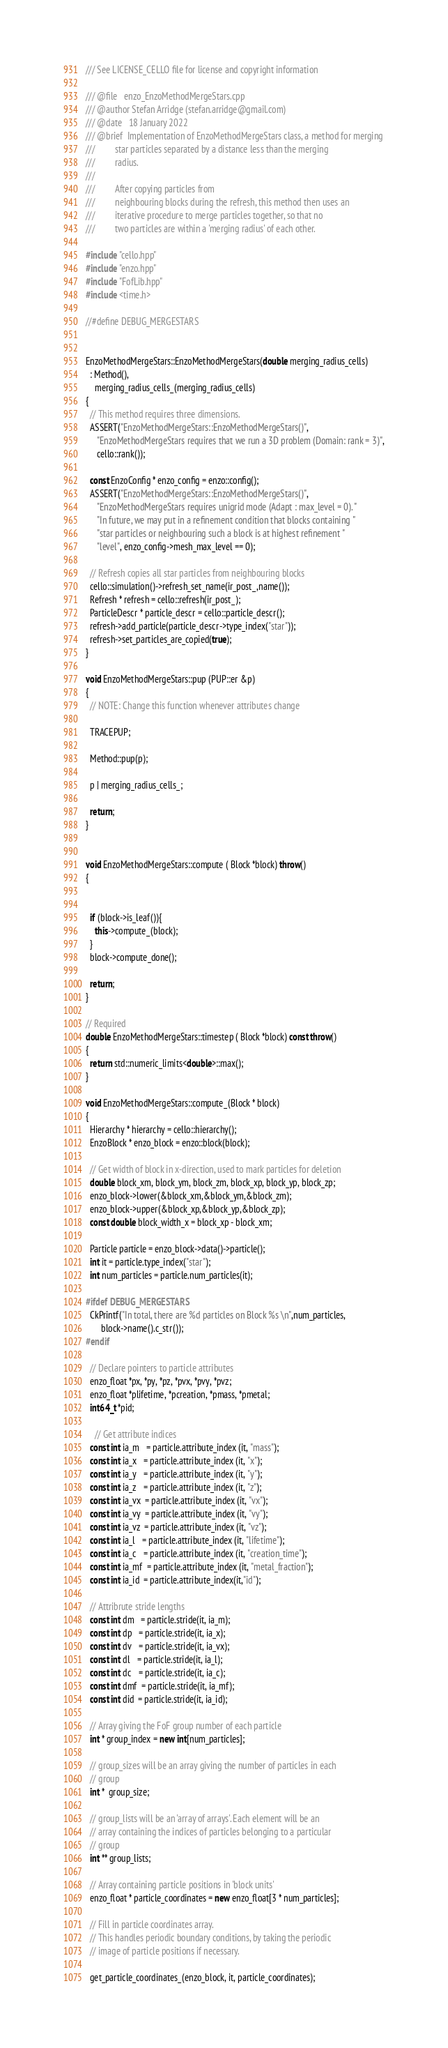<code> <loc_0><loc_0><loc_500><loc_500><_C++_>/// See LICENSE_CELLO file for license and copyright information

/// @file   enzo_EnzoMethodMergeStars.cpp
/// @author Stefan Arridge (stefan.arridge@gmail.com)
/// @date   18 January 2022
/// @brief  Implementation of EnzoMethodMergeStars class, a method for merging
///         star particles separated by a distance less than the merging
///         radius.
///
///         After copying particles from
///         neighbouring blocks during the refresh, this method then uses an
///         iterative procedure to merge particles together, so that no
///         two particles are within a 'merging radius' of each other.

#include "cello.hpp"
#include "enzo.hpp"
#include "FofLib.hpp"
#include <time.h>

//#define DEBUG_MERGESTARS


EnzoMethodMergeStars::EnzoMethodMergeStars(double merging_radius_cells)
  : Method(),
    merging_radius_cells_(merging_radius_cells)
{
  // This method requires three dimensions.
  ASSERT("EnzoMethodMergeStars::EnzoMethodMergeStars()",
	 "EnzoMethodMergeStars requires that we run a 3D problem (Domain: rank = 3)",
	 cello::rank());
  
  const EnzoConfig * enzo_config = enzo::config();
  ASSERT("EnzoMethodMergeStars::EnzoMethodMergeStars()",
	 "EnzoMethodMergeStars requires unigrid mode (Adapt : max_level = 0). "
	 "In future, we may put in a refinement condition that blocks containing "
	 "star particles or neighbouring such a block is at highest refinement "
	 "level", enzo_config->mesh_max_level == 0);

  // Refresh copies all star particles from neighbouring blocks
  cello::simulation()->refresh_set_name(ir_post_,name());
  Refresh * refresh = cello::refresh(ir_post_);
  ParticleDescr * particle_descr = cello::particle_descr();
  refresh->add_particle(particle_descr->type_index("star"));
  refresh->set_particles_are_copied(true);
}

void EnzoMethodMergeStars::pup (PUP::er &p)
{
  // NOTE: Change this function whenever attributes change

  TRACEPUP;

  Method::pup(p);

  p | merging_radius_cells_;
 
  return;
}


void EnzoMethodMergeStars::compute ( Block *block) throw()
{

  
  if (block->is_leaf()){
    this->compute_(block);
  }
  block->compute_done();

  return;
}

// Required
double EnzoMethodMergeStars::timestep ( Block *block) const throw()
{
  return std::numeric_limits<double>::max();
}

void EnzoMethodMergeStars::compute_(Block * block)
{
  Hierarchy * hierarchy = cello::hierarchy();  
  EnzoBlock * enzo_block = enzo::block(block);
  
  // Get width of block in x-direction, used to mark particles for deletion
  double block_xm, block_ym, block_zm, block_xp, block_yp, block_zp;
  enzo_block->lower(&block_xm,&block_ym,&block_zm);
  enzo_block->upper(&block_xp,&block_yp,&block_zp);
  const double block_width_x = block_xp - block_xm;
  
  Particle particle = enzo_block->data()->particle();
  int it = particle.type_index("star");
  int num_particles = particle.num_particles(it);
  
#ifdef DEBUG_MERGESTARS
  CkPrintf("In total, there are %d particles on Block %s \n",num_particles,
	   block->name().c_str());
#endif

  // Declare pointers to particle attributes
  enzo_float *px, *py, *pz, *pvx, *pvy, *pvz;
  enzo_float *plifetime, *pcreation, *pmass, *pmetal;
  int64_t *pid;
  
    // Get attribute indices
  const int ia_m   = particle.attribute_index (it, "mass");
  const int ia_x   = particle.attribute_index (it, "x");
  const int ia_y   = particle.attribute_index (it, "y");
  const int ia_z   = particle.attribute_index (it, "z");
  const int ia_vx  = particle.attribute_index (it, "vx");
  const int ia_vy  = particle.attribute_index (it, "vy");
  const int ia_vz  = particle.attribute_index (it, "vz");
  const int ia_l   = particle.attribute_index (it, "lifetime");
  const int ia_c   = particle.attribute_index (it, "creation_time");
  const int ia_mf  = particle.attribute_index (it, "metal_fraction");
  const int ia_id  = particle.attribute_index(it,"id");
  
  // Attribrute stride lengths
  const int dm   = particle.stride(it, ia_m);
  const int dp   = particle.stride(it, ia_x);
  const int dv   = particle.stride(it, ia_vx);
  const int dl   = particle.stride(it, ia_l);
  const int dc   = particle.stride(it, ia_c);
  const int dmf  = particle.stride(it, ia_mf);
  const int did  = particle.stride(it, ia_id);
      
  // Array giving the FoF group number of each particle
  int * group_index = new int[num_particles];
  
  // group_sizes will be an array giving the number of particles in each
  // group
  int *  group_size;
  
  // group_lists will be an 'array of arrays'. Each element will be an
  // array containing the indices of particles belonging to a particular
  // group
  int ** group_lists;
  
  // Array containing particle positions in 'block units'
  enzo_float * particle_coordinates = new enzo_float[3 * num_particles];
      
  // Fill in particle coordinates array.
  // This handles periodic boundary conditions, by taking the periodic
  // image of particle positions if necessary.
  
  get_particle_coordinates_(enzo_block, it, particle_coordinates);
</code> 